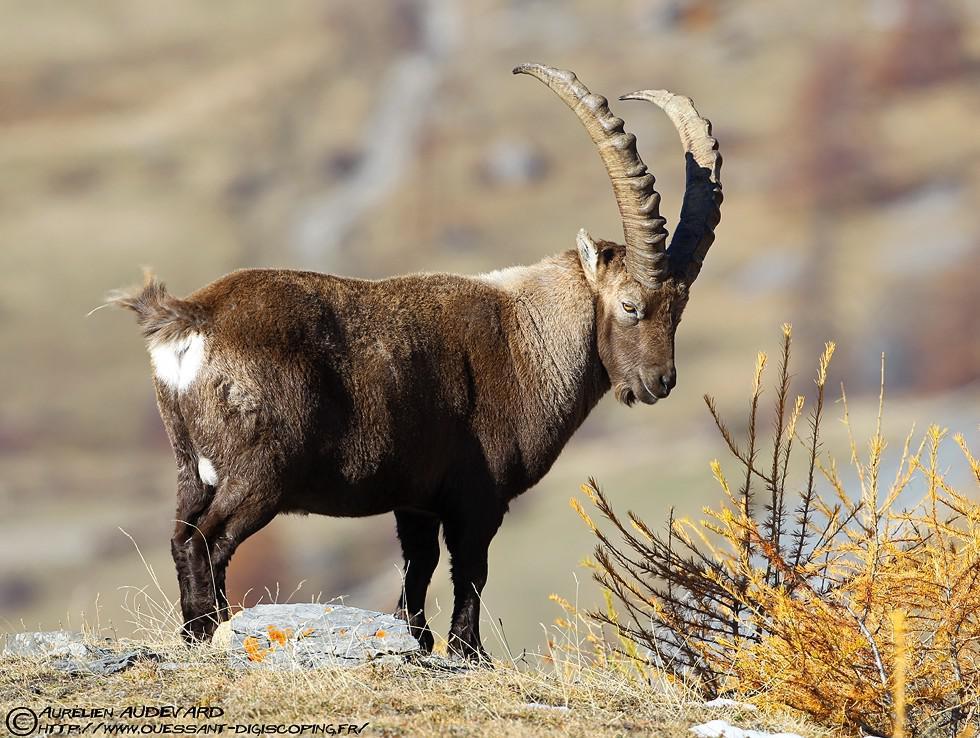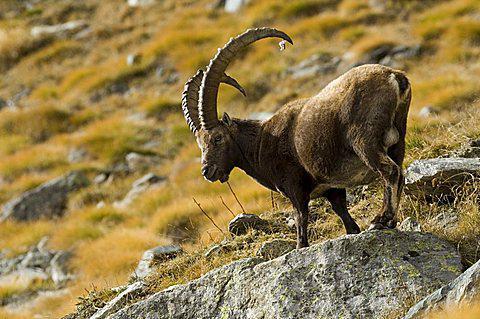The first image is the image on the left, the second image is the image on the right. Given the left and right images, does the statement "There is exactly one sitting animal in the image on the right." hold true? Answer yes or no. No. The first image is the image on the left, the second image is the image on the right. Evaluate the accuracy of this statement regarding the images: "In one image, an antelope is resting with its body on the ground.". Is it true? Answer yes or no. No. 